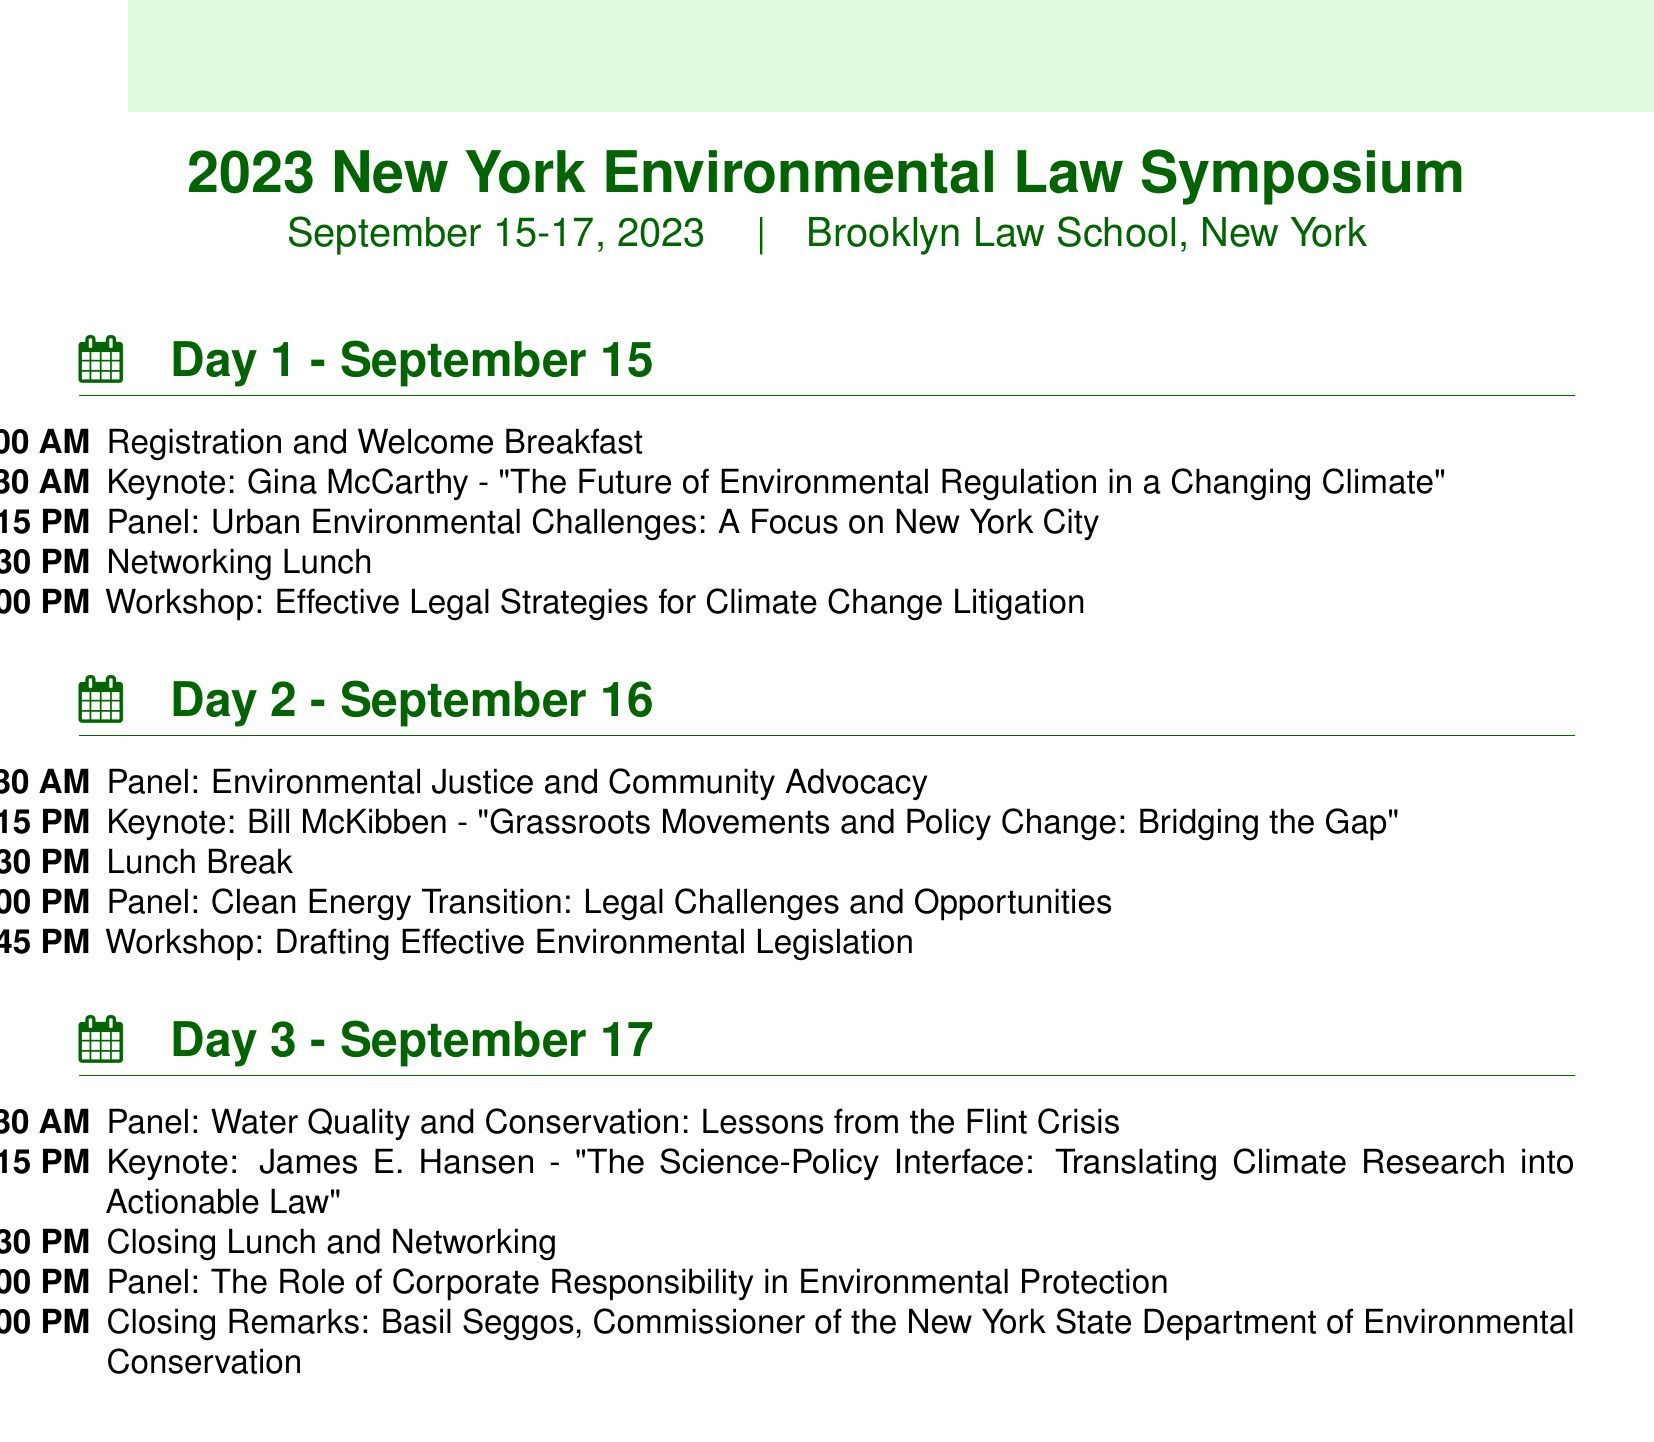What is the conference name? The conference name is explicitly stated in the document as the title.
Answer: 2023 New York Environmental Law Symposium Who is the keynote speaker for Day 1? The document lists the keynote speakers under their respective days.
Answer: Gina McCarthy What time does the registration and welcome breakfast start? The time is specified in the schedule for the first event on Day 1.
Answer: 9:00 AM How many panel discussions are there on Day 2? The document summarizes the events by type, counting the panel discussions listed on Day 2.
Answer: 2 What is the title of the workshop on Day 1? Each workshop title is stated next to the event type in the schedule.
Answer: Effective Legal Strategies for Climate Change Litigation Who is the facilitator for the workshop on Day 2? The document specifically names the facilitator for this event in the schedule.
Answer: Richard Revesz What is the topic of James E. Hansen's keynote address? The topic is provided under the details of the keynote address on Day 3.
Answer: The Science-Policy Interface: Translating Climate Research into Actionable Law Who will give the closing remarks at the conference? The document lists the individual responsible for closing remarks at the end of Day 3.
Answer: Basil Seggos What topic does the panel on Day 3 focus on? The document includes the title of the panel discussion in the schedule for Day 3.
Answer: The Role of Corporate Responsibility in Environmental Protection 